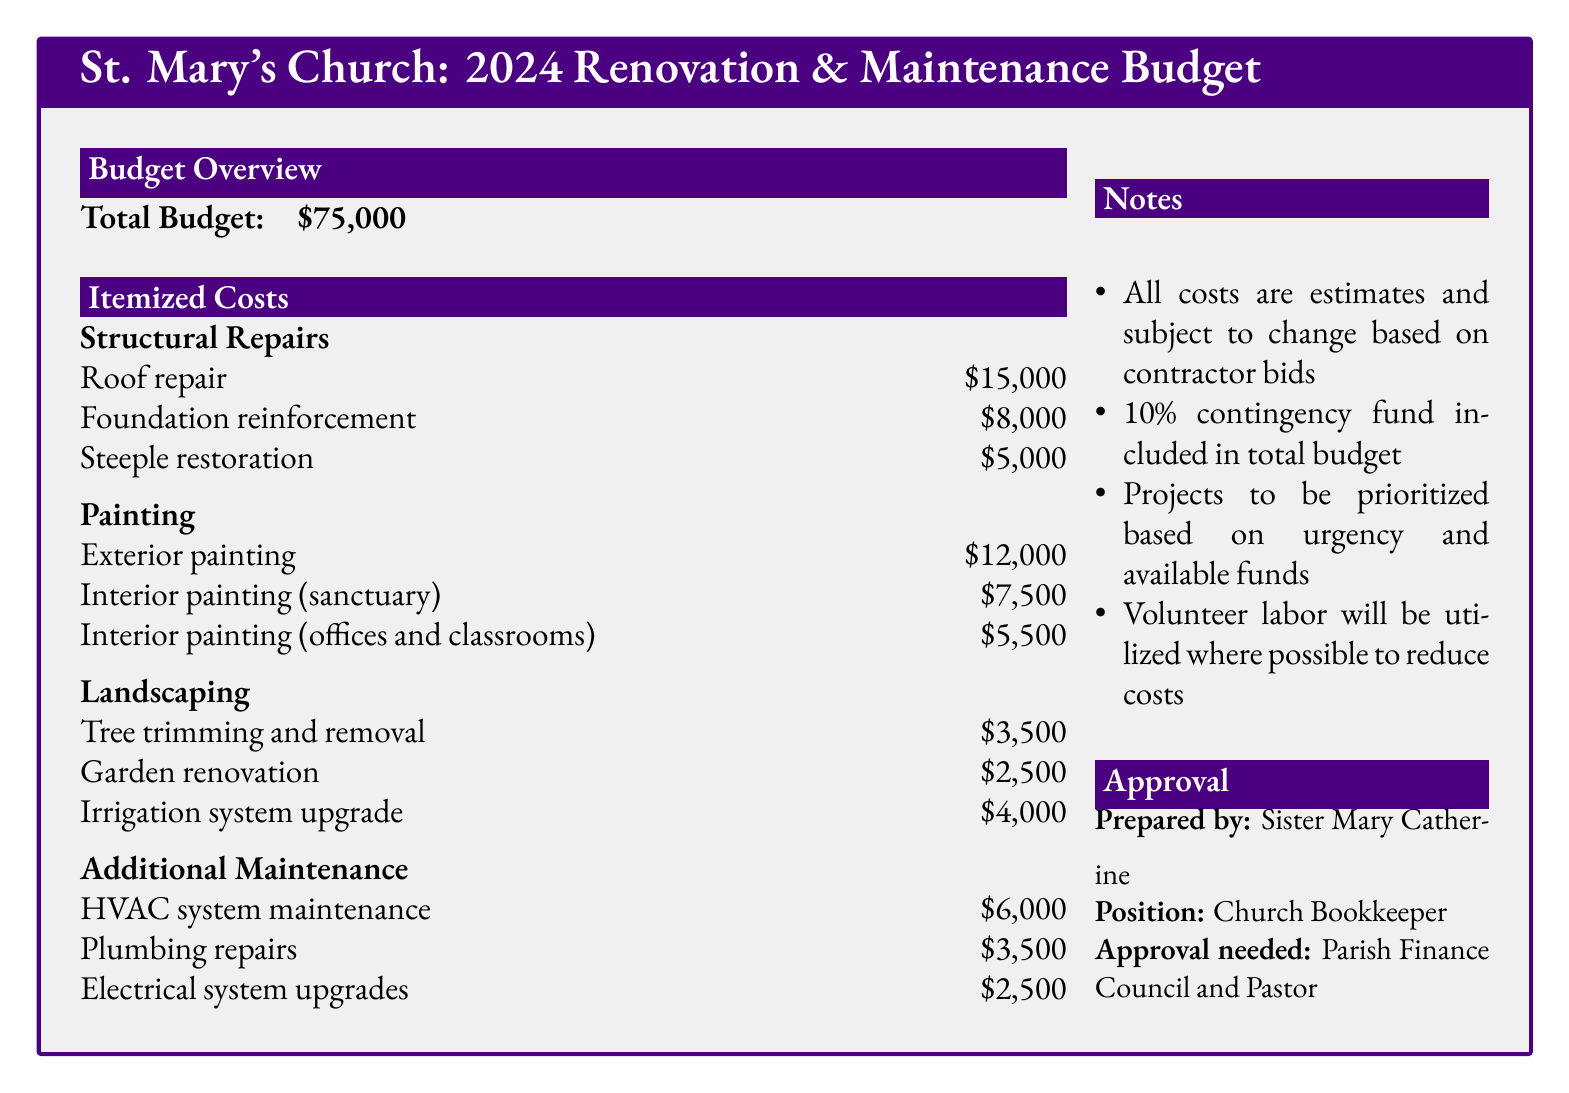What is the total budget for the church renovations? The total budget listed in the document is explicitly stated as $75,000.
Answer: $75,000 How much is allocated for roof repair? The document specifies that roof repair costs $15,000.
Answer: $15,000 What is the cost for interior painting in the sanctuary? The document mentions that interior painting (sanctuary) amounts to $7,500.
Answer: $7,500 Which item has the highest cost under structural repairs? The highest cost under structural repairs is indicated as roof repair, which is $15,000.
Answer: Roof repair What percentage is included for the contingency fund? The document states that a 10% contingency fund is included in the total budget.
Answer: 10% How much is budgeted for tree trimming and removal? The specific budget for tree trimming and removal is listed as $3,500 in the landscaping section.
Answer: $3,500 Who prepared the budget document? The budget document indicates that it was prepared by Sister Mary Catherine.
Answer: Sister Mary Catherine What is the total cost for all types of painting combined? The total cost for all painting categories is calculated by adding exterior and interior painting costs, resulting in $25,000.
Answer: $25,000 What kind of system is mentioned for maintenance? The document references HVAC system maintenance as a part of the budget.
Answer: HVAC system 